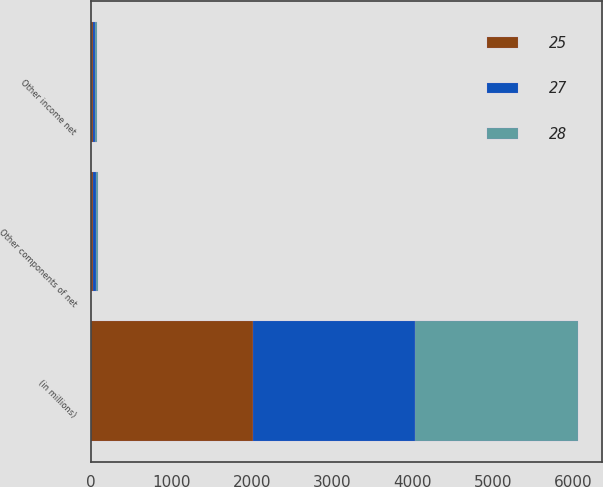<chart> <loc_0><loc_0><loc_500><loc_500><stacked_bar_chart><ecel><fcel>(in millions)<fcel>Other components of net<fcel>Other income net<nl><fcel>27<fcel>2018<fcel>30<fcel>25<nl><fcel>28<fcel>2017<fcel>27<fcel>27<nl><fcel>25<fcel>2016<fcel>28<fcel>28<nl></chart> 